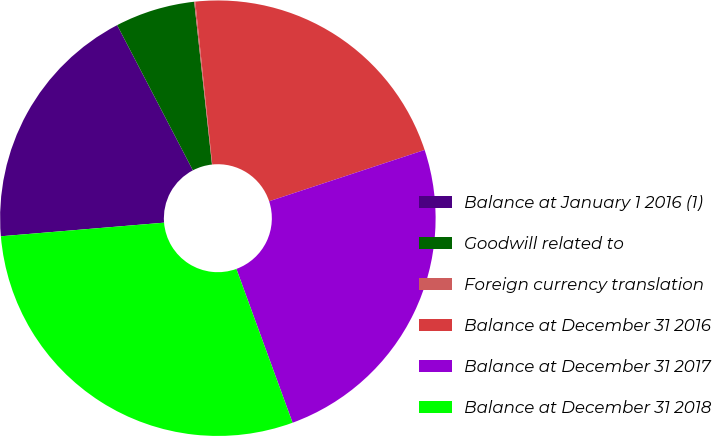Convert chart. <chart><loc_0><loc_0><loc_500><loc_500><pie_chart><fcel>Balance at January 1 2016 (1)<fcel>Goodwill related to<fcel>Foreign currency translation<fcel>Balance at December 31 2016<fcel>Balance at December 31 2017<fcel>Balance at December 31 2018<nl><fcel>18.67%<fcel>5.92%<fcel>0.08%<fcel>21.58%<fcel>24.5%<fcel>29.25%<nl></chart> 